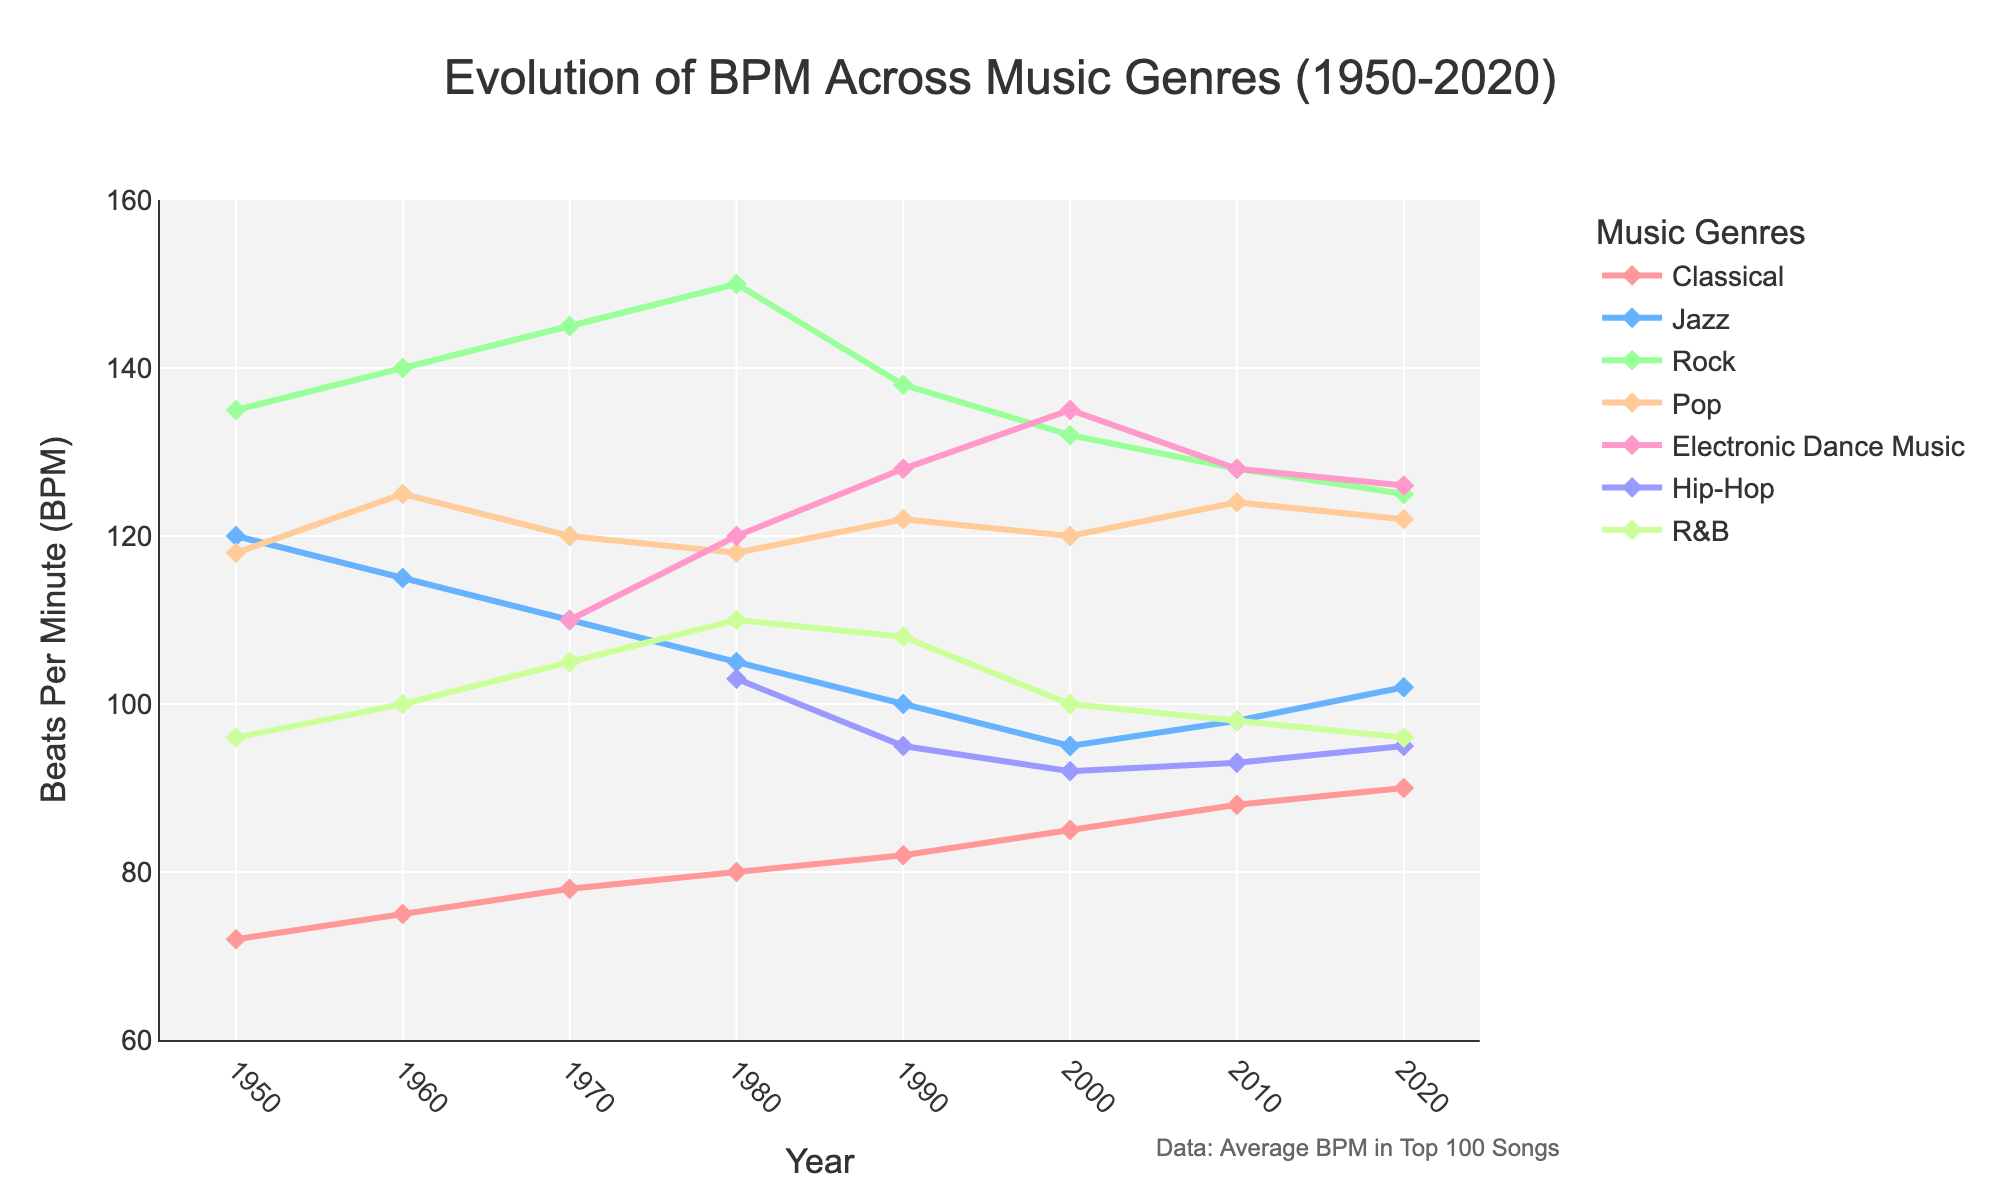How has the BPM of Classical music changed from 1950 to 2020? The BPM for Classical music in 1950 is 72, and by 2020 it is 90. Subtracting the two values: 90 - 72 = 18.
Answer: Increased by 18 Which genre has the highest BPM in 1980 and what is its value? In 1980, Rock has the highest BPM at 150. This is evident by comparing the BPM values across all genres in that year.
Answer: Rock, 150 What is the average BPM of Pop music in the 1990s and 2000s? The BPM for Pop music in 1990 is 122, and in 2000 it is 120. The average is calculated as (122 + 120)/2 = 121.
Answer: 121 Between which two decades did Jazz music experience the largest drop in BPM? The BPM for Jazz music are: 1950 - 120, 1960 - 115, 1970 - 110, 1980 - 105, 1990 - 100, 2000 - 95, 2010 - 98, 2020 - 102. The largest drop is between 2000 and 2010 (95 to 98).
Answer: 2000 to 2010 Which genre shows the most increase in BPM from 1980 to 2020? Calculate the difference for each genre from 1980 to 2020: Classical (10), Jazz (-3), Rock (-25), Pop (4), Electronic Dance Music (6), Hip-Hop (-8), R&B (-14). Classical shows the greatest increase.
Answer: Classical What is the difference in BPM between Rock and Hip-Hop in 2010? In 2010, Rock BPM is 128 and Hip-Hop BPM is 93. The difference is 128 - 93 = 35.
Answer: 35 Which genre had the most stable BPM during the 70-year period? Looking at the trends, R&B appears to be the most stable, with values fluctuating slightly around 100.
Answer: R&B Of the genres listed, which has the widest BPM range in 2020? For 2020, the BPM values: Classical (90), Jazz (102), Rock (125), Pop (122), Electronic Dance Music (126), Hip-Hop (95), R&B (96). The range is the highest for Rock (125 - 90 = 35).
Answer: Rock 